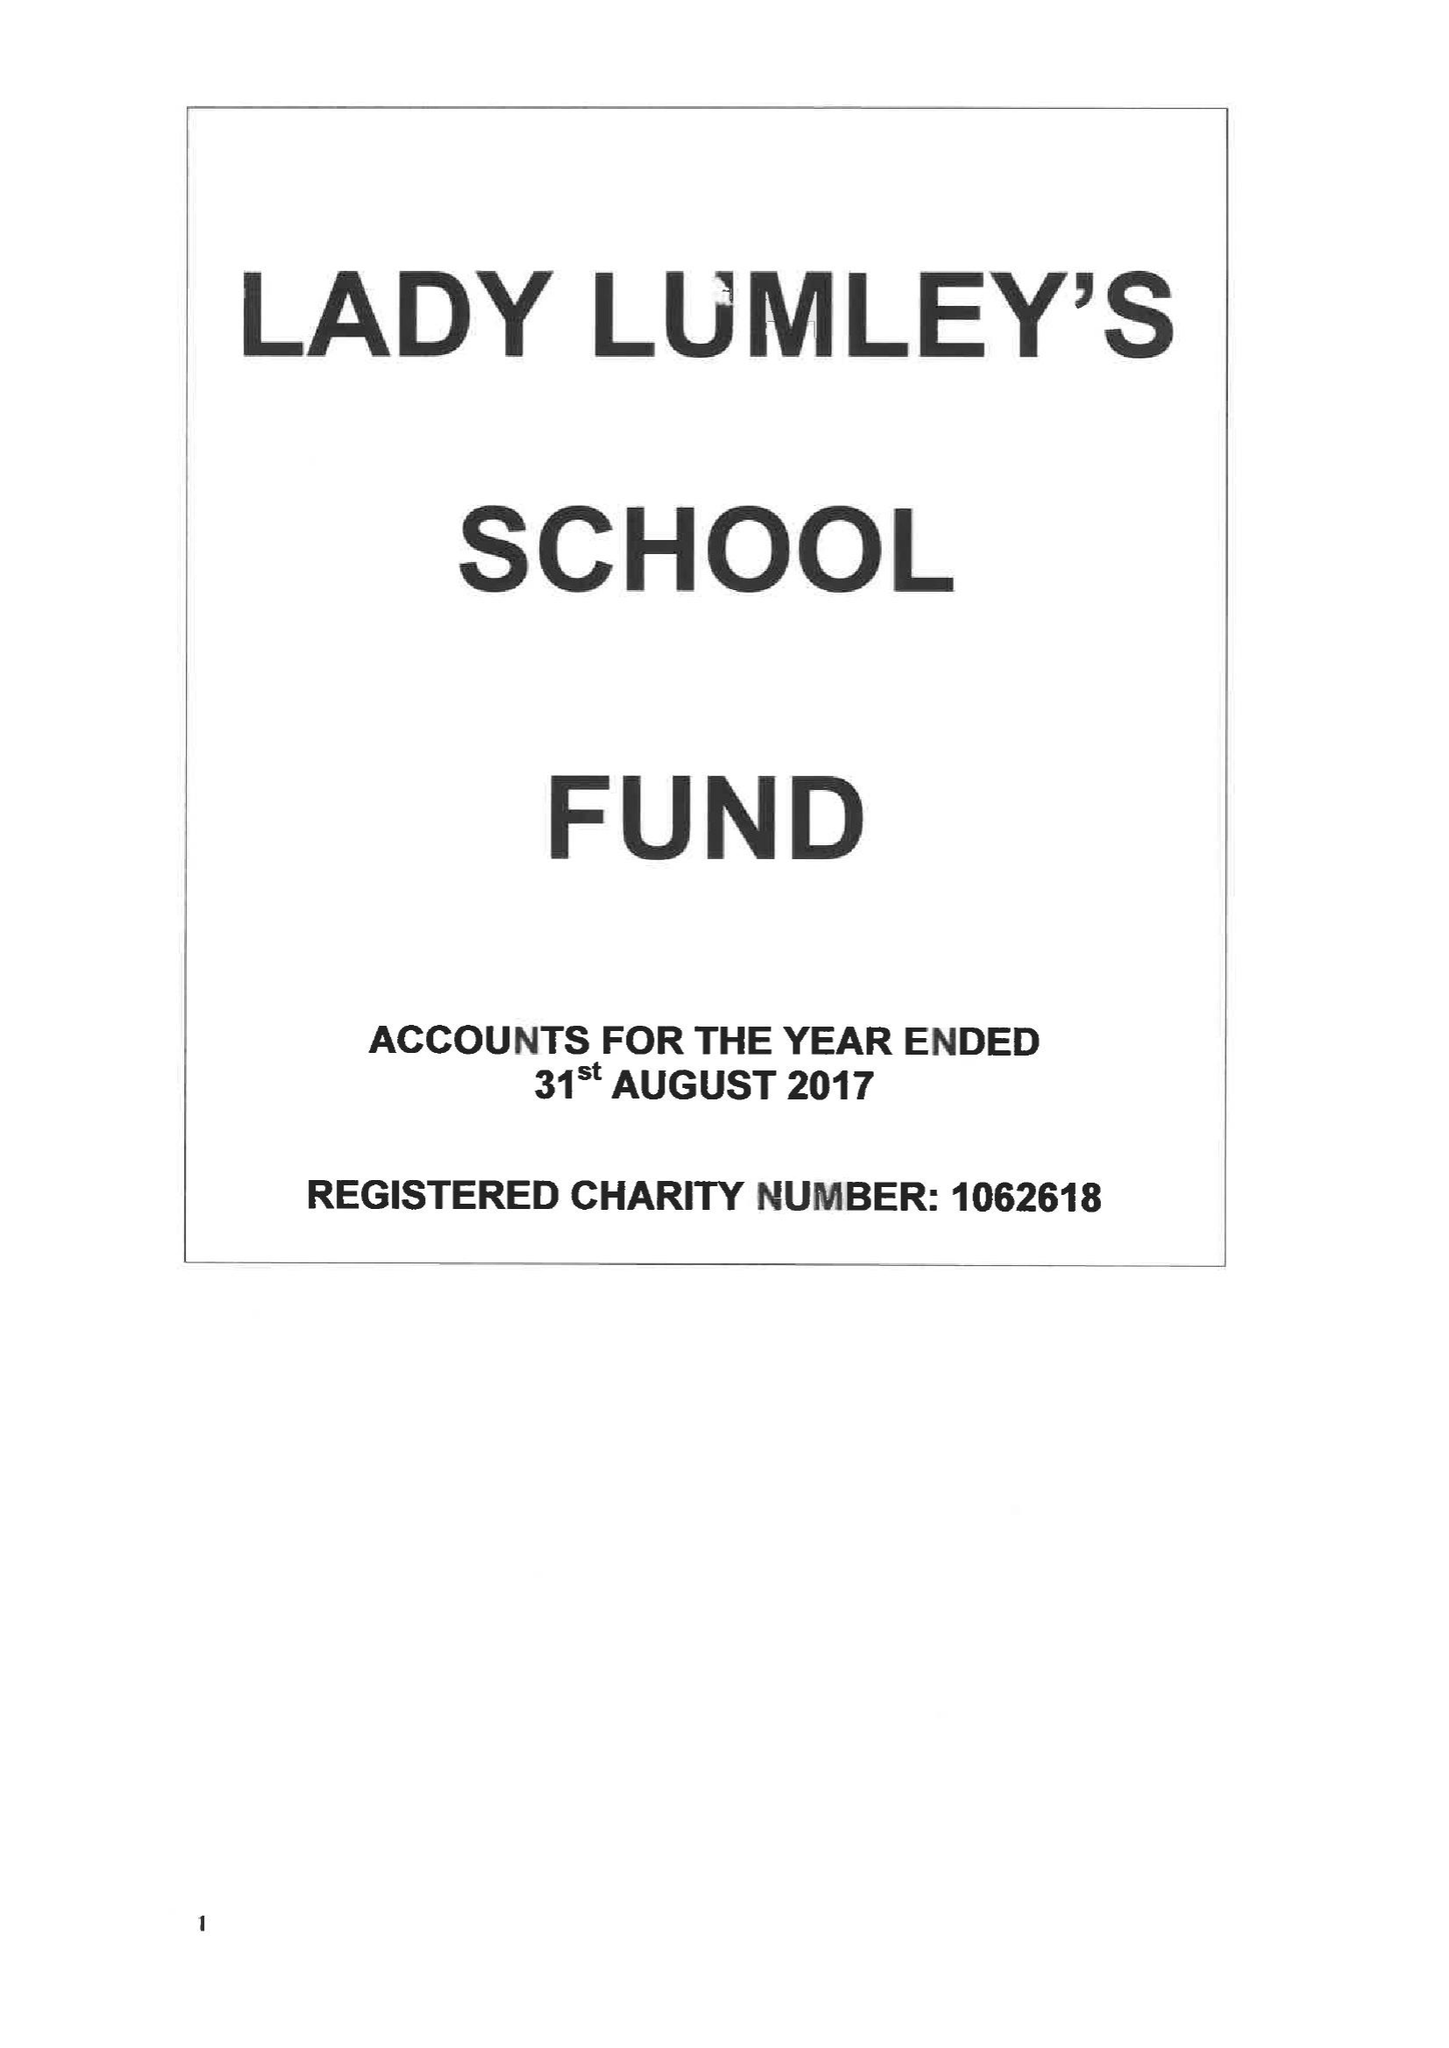What is the value for the charity_name?
Answer the question using a single word or phrase. Lady Lumley's School Fund 